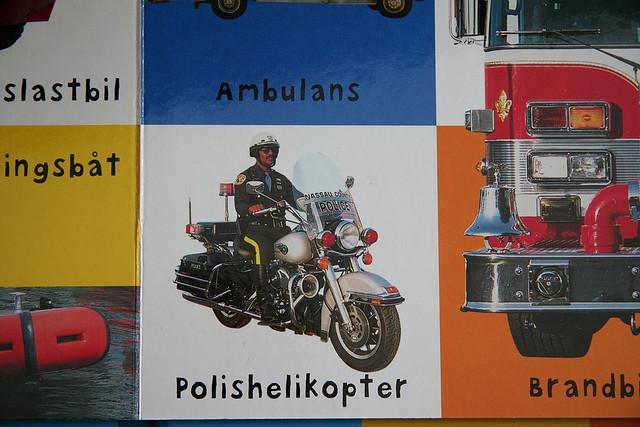What is the name of the drawing at the bottom left corner?
Short answer required. Polishelikopter. Who is on the bike?
Give a very brief answer. Policeman. What color is the motorcycle?
Give a very brief answer. Black. Are the words in this photo in English?
Be succinct. No. 